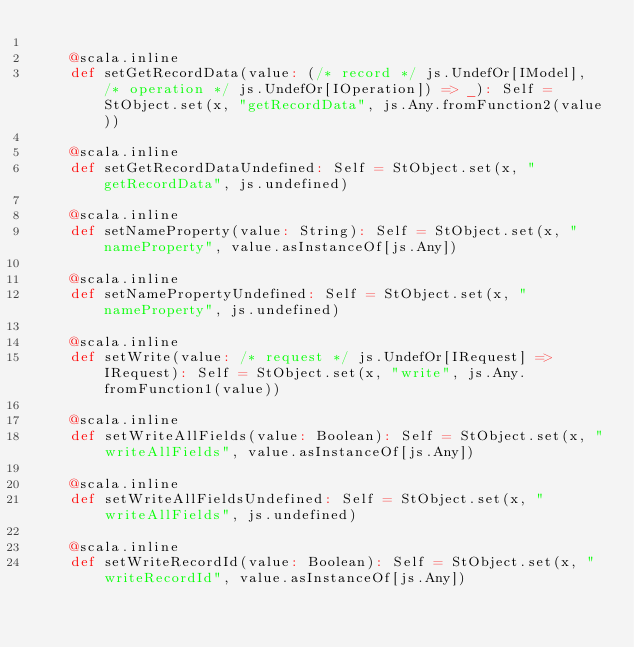<code> <loc_0><loc_0><loc_500><loc_500><_Scala_>    
    @scala.inline
    def setGetRecordData(value: (/* record */ js.UndefOr[IModel], /* operation */ js.UndefOr[IOperation]) => _): Self = StObject.set(x, "getRecordData", js.Any.fromFunction2(value))
    
    @scala.inline
    def setGetRecordDataUndefined: Self = StObject.set(x, "getRecordData", js.undefined)
    
    @scala.inline
    def setNameProperty(value: String): Self = StObject.set(x, "nameProperty", value.asInstanceOf[js.Any])
    
    @scala.inline
    def setNamePropertyUndefined: Self = StObject.set(x, "nameProperty", js.undefined)
    
    @scala.inline
    def setWrite(value: /* request */ js.UndefOr[IRequest] => IRequest): Self = StObject.set(x, "write", js.Any.fromFunction1(value))
    
    @scala.inline
    def setWriteAllFields(value: Boolean): Self = StObject.set(x, "writeAllFields", value.asInstanceOf[js.Any])
    
    @scala.inline
    def setWriteAllFieldsUndefined: Self = StObject.set(x, "writeAllFields", js.undefined)
    
    @scala.inline
    def setWriteRecordId(value: Boolean): Self = StObject.set(x, "writeRecordId", value.asInstanceOf[js.Any])
    </code> 